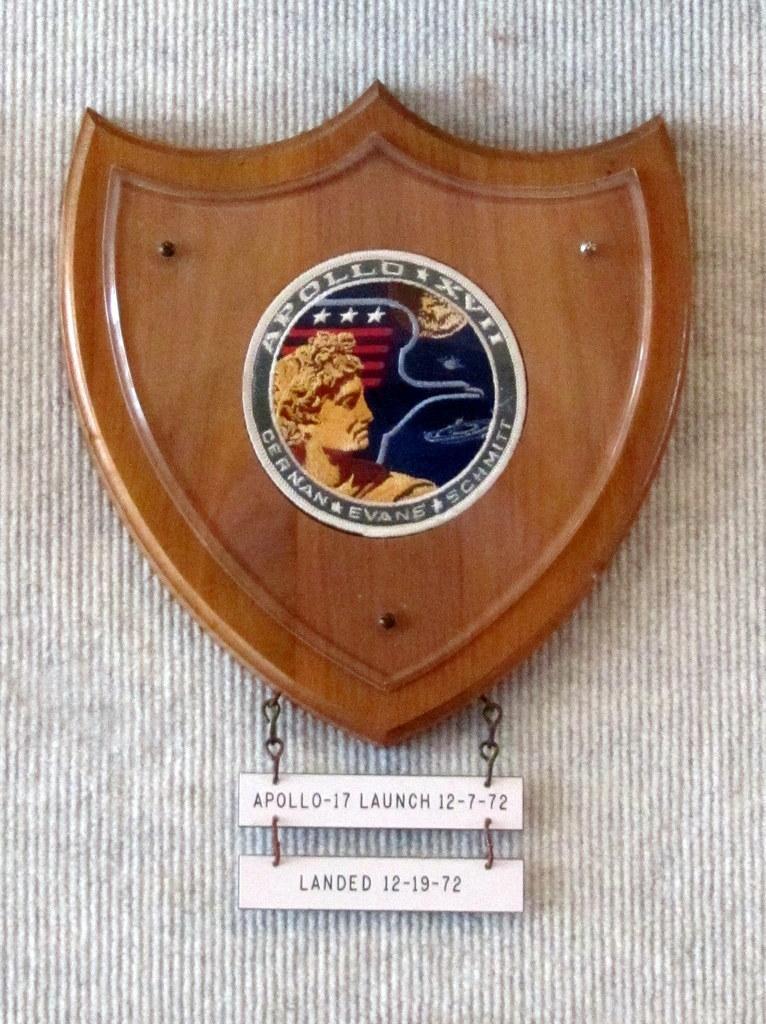Please provide a concise description of this image. In this picture, we see a badge containing the space mission patch. Below that, we see the small boards with text written on it. In the background, it is grey in color. 